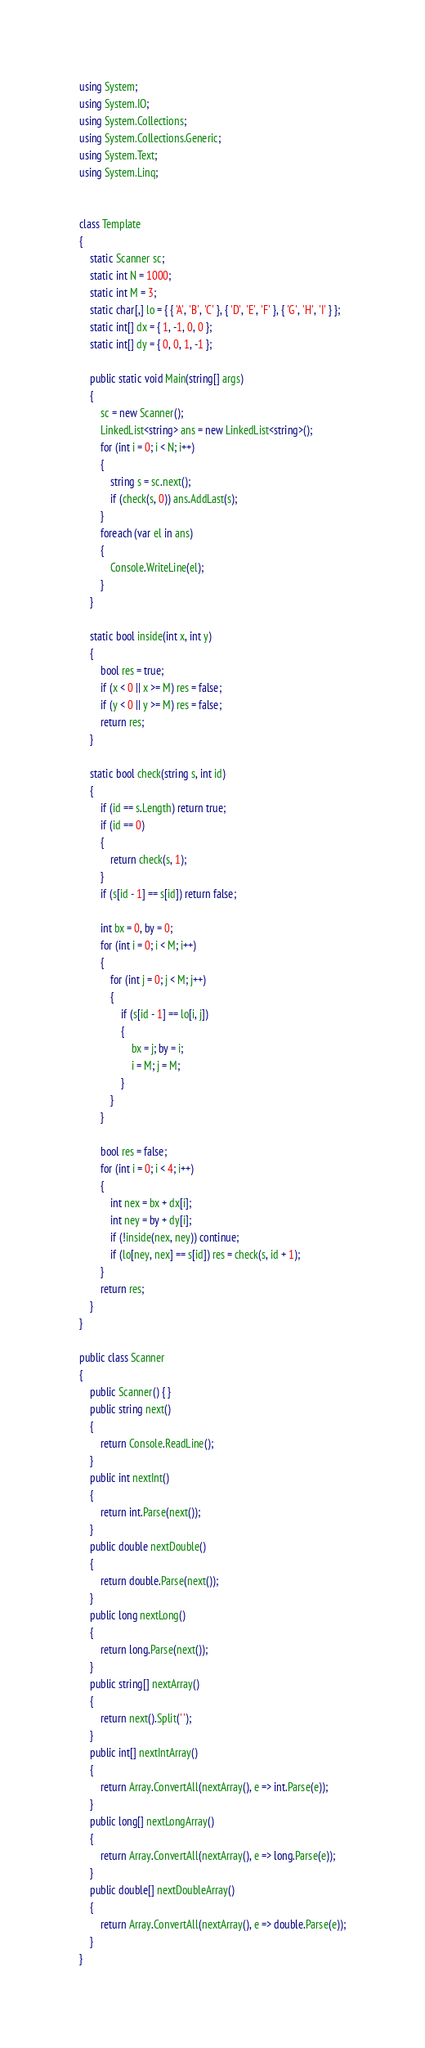Convert code to text. <code><loc_0><loc_0><loc_500><loc_500><_C#_>using System;
using System.IO;
using System.Collections;
using System.Collections.Generic;
using System.Text;
using System.Linq;


class Template
{
	static Scanner sc;
	static int N = 1000;
	static int M = 3;
	static char[,] lo = { { 'A', 'B', 'C' }, { 'D', 'E', 'F' }, { 'G', 'H', 'I' } };
	static int[] dx = { 1, -1, 0, 0 };
	static int[] dy = { 0, 0, 1, -1 };

	public static void Main(string[] args)
	{
		sc = new Scanner();
		LinkedList<string> ans = new LinkedList<string>();
		for (int i = 0; i < N; i++)
		{
			string s = sc.next();
			if (check(s, 0)) ans.AddLast(s);
		}
		foreach (var el in ans)
		{
			Console.WriteLine(el);
		}
	}

	static bool inside(int x, int y)
	{
		bool res = true;
		if (x < 0 || x >= M) res = false;
		if (y < 0 || y >= M) res = false;
		return res;
	}

	static bool check(string s, int id)
	{
		if (id == s.Length) return true;
		if (id == 0)
		{
			return check(s, 1);
		}
		if (s[id - 1] == s[id]) return false;

		int bx = 0, by = 0;
		for (int i = 0; i < M; i++)
		{
			for (int j = 0; j < M; j++)
			{
				if (s[id - 1] == lo[i, j])
				{
					bx = j; by = i;
					i = M; j = M;
				}
			}
		}

		bool res = false;
		for (int i = 0; i < 4; i++)
		{
			int nex = bx + dx[i];
			int ney = by + dy[i];
			if (!inside(nex, ney)) continue;
			if (lo[ney, nex] == s[id]) res = check(s, id + 1);
		}
		return res;
	}
}

public class Scanner
{
	public Scanner() { }
	public string next()
	{
		return Console.ReadLine();
	}
	public int nextInt()
	{
		return int.Parse(next());
	}
	public double nextDouble()
	{
		return double.Parse(next());
	}
	public long nextLong()
	{
		return long.Parse(next());
	}
	public string[] nextArray()
	{
		return next().Split(' ');
	}
	public int[] nextIntArray()
	{
		return Array.ConvertAll(nextArray(), e => int.Parse(e));
	}
	public long[] nextLongArray()
	{
		return Array.ConvertAll(nextArray(), e => long.Parse(e));
	}
	public double[] nextDoubleArray()
	{
		return Array.ConvertAll(nextArray(), e => double.Parse(e));
	}
}</code> 